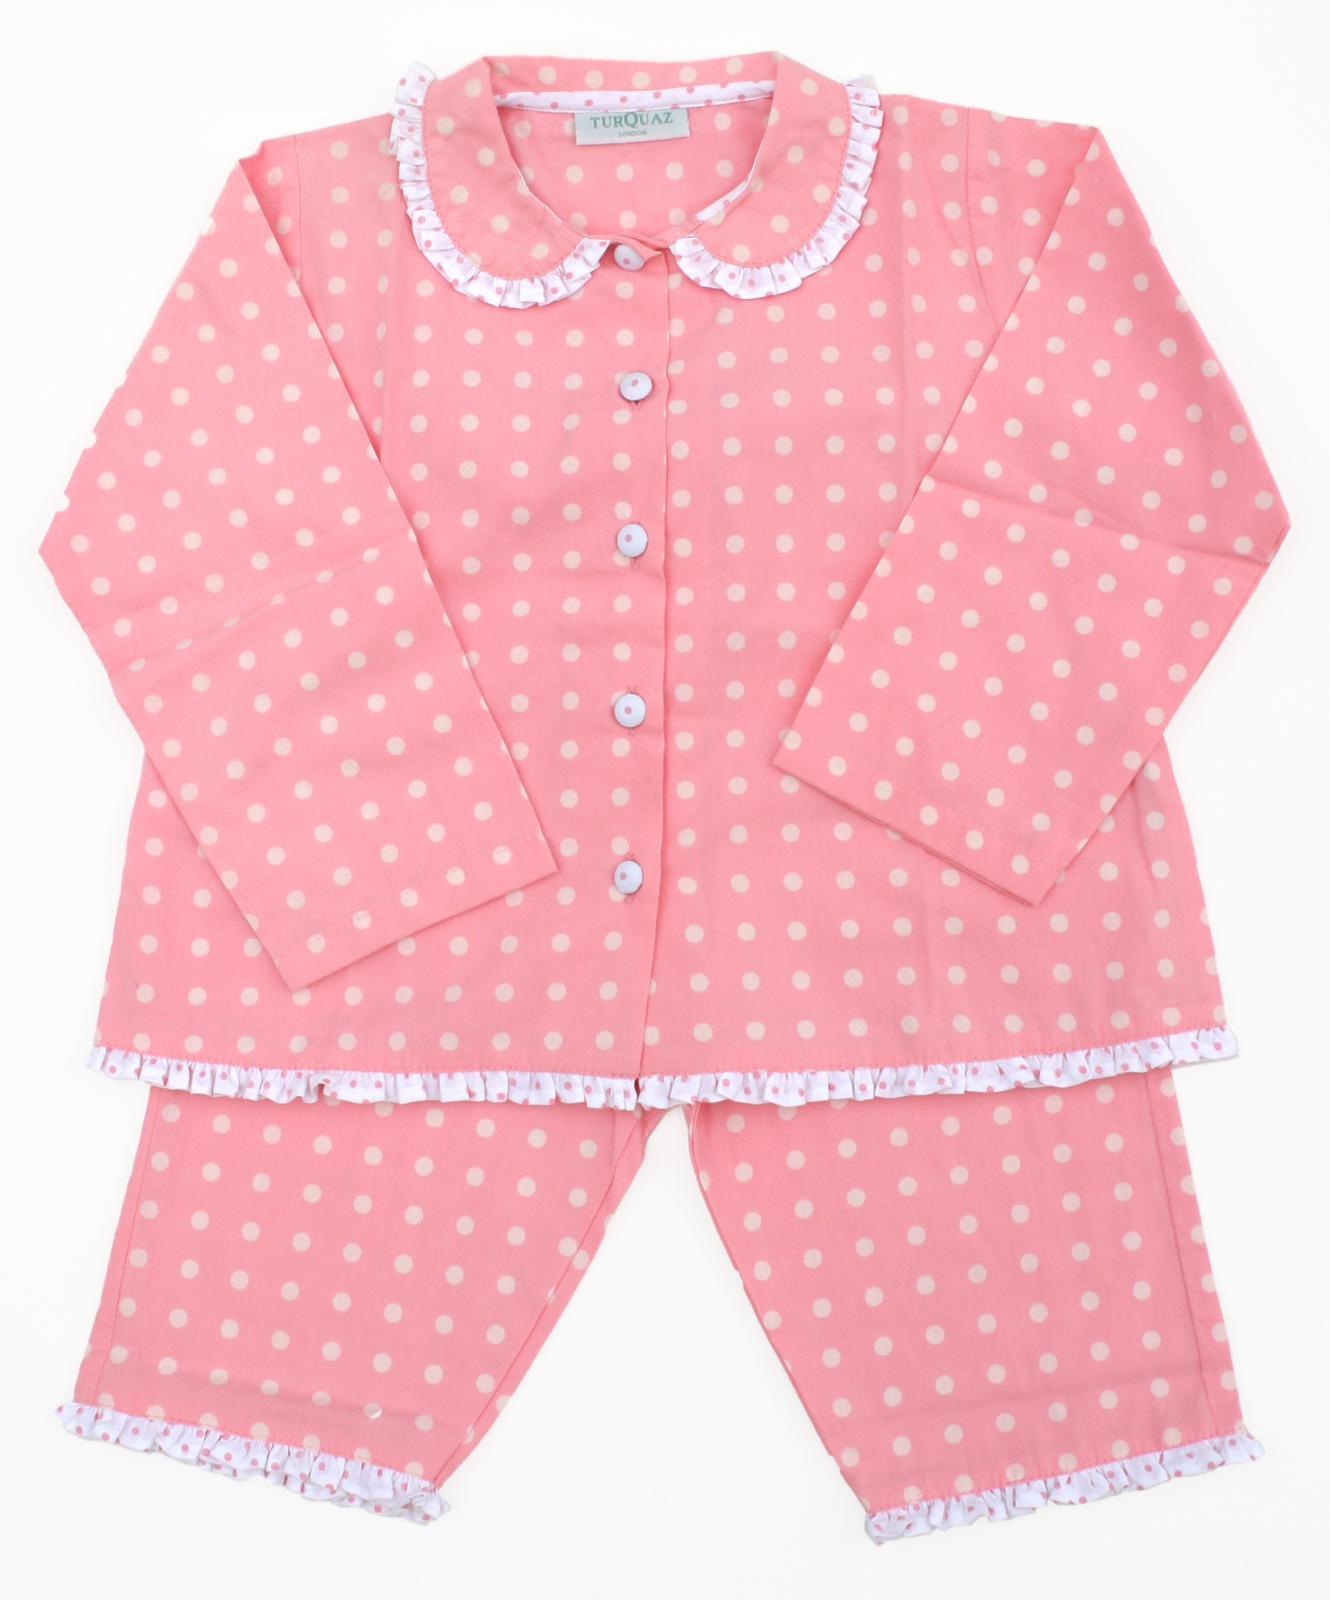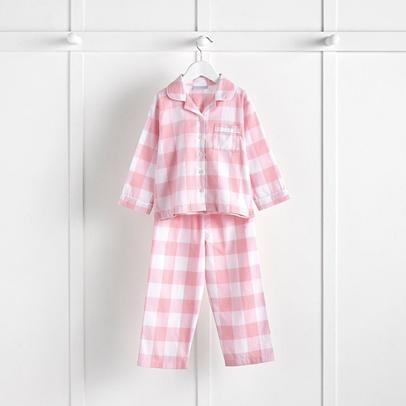The first image is the image on the left, the second image is the image on the right. Given the left and right images, does the statement "An image shows a set of loungewear that features a mostly solid-colored long-sleeved top and a coordinating pair of patterned leggings." hold true? Answer yes or no. No. The first image is the image on the left, the second image is the image on the right. Analyze the images presented: Is the assertion "A two-piece pajama set in one image has a pullover top with applique in the chest area, with wide cuffs on the shirt sleeves and pant legs." valid? Answer yes or no. No. 